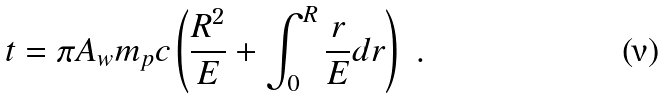Convert formula to latex. <formula><loc_0><loc_0><loc_500><loc_500>t = \pi A _ { w } m _ { p } c \left ( \frac { R ^ { 2 } } { E } + \int ^ { R } _ { 0 } \frac { r } { E } d r \right ) \ .</formula> 